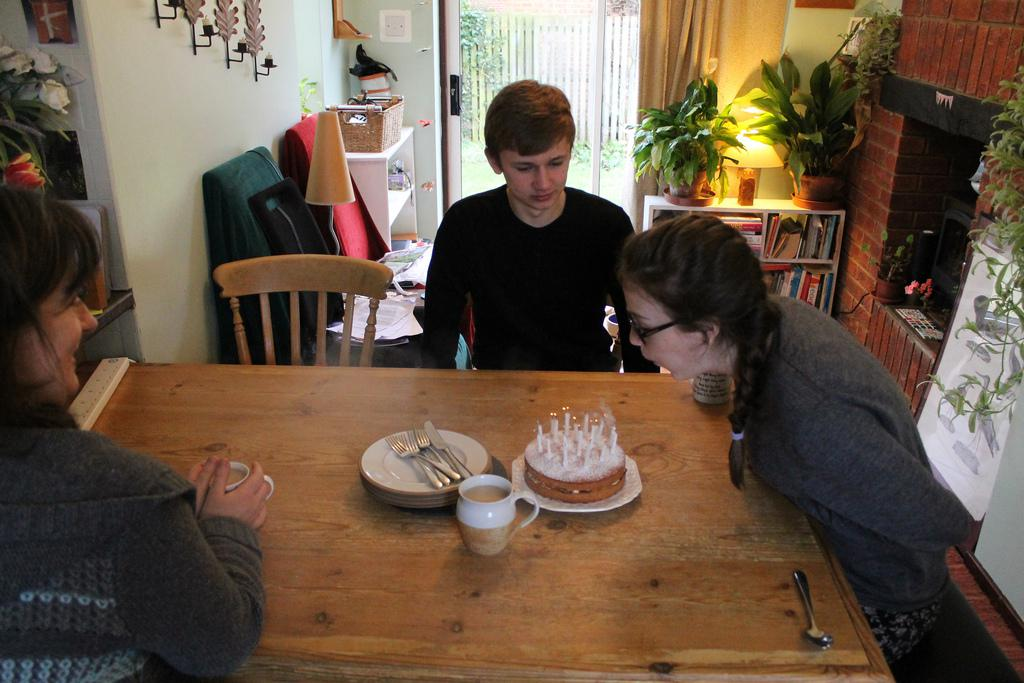Question: what are they celebrating?
Choices:
A. Anniversary.
B. Birthday.
C. Graduation.
D. Mothers Day.
Answer with the letter. Answer: B Question: where are they sitting?
Choices:
A. At a chair.
B. At a bench.
C. At a desk.
D. At a table.
Answer with the letter. Answer: D Question: how many layers is the cake?
Choices:
A. 2.
B. 3.
C. 5.
D. 1.
Answer with the letter. Answer: A Question: how many people are sitting at the table?
Choices:
A. 4.
B. 5.
C. 3.
D. 6.
Answer with the letter. Answer: C Question: how is the young girls hir styled?
Choices:
A. Weave.
B. French braid.
C. Classic.
D. Ponytail.
Answer with the letter. Answer: B Question: what is the young girl wearing on her face?
Choices:
A. A bandana.
B. A sticker.
C. Glasses.
D. Facepaint.
Answer with the letter. Answer: C Question: what is the table made of?
Choices:
A. Glass.
B. Wood.
C. Metal.
D. Plastic.
Answer with the letter. Answer: B Question: where is the fireplace?
Choices:
A. In the bedroom.
B. In the room.
C. In the lobby.
D. In the hotel room.
Answer with the letter. Answer: B Question: what is the woman wearing?
Choices:
A. A mask.
B. A hat.
C. Glasses.
D. A hood.
Answer with the letter. Answer: C Question: how is the woman's hair styled?
Choices:
A. A bun.
B. A mohawk.
C. In pigtails.
D. A braid.
Answer with the letter. Answer: D Question: what is the young girl doing?
Choices:
A. Blowing out dust.
B. Blowing out leaves.
C. Blowing out candles.
D. Blowing out papers.
Answer with the letter. Answer: C Question: what are the green objects next to the lamp in the background?
Choices:
A. Balls.
B. Toys.
C. Plants.
D. Coasters.
Answer with the letter. Answer: C Question: what is on top of the bookcase in the background?
Choices:
A. A book and pen.
B. A light and pencil.
C. A lamp and plants.
D. A backpack and crayon.
Answer with the letter. Answer: C Question: what is the Mother doing?
Choices:
A. Holding the baby.
B. Brushing the girl's hair.
C. Smiling.
D. Holding the birthday cake.
Answer with the letter. Answer: C Question: where is the light coming from?
Choices:
A. From the door.
B. From the Neon sign.
C. From the street light.
D. From the candles.
Answer with the letter. Answer: A Question: how many plates are stacked on the table?
Choices:
A. 3.
B. 2.
C. 4.
D. 5.
Answer with the letter. Answer: A 